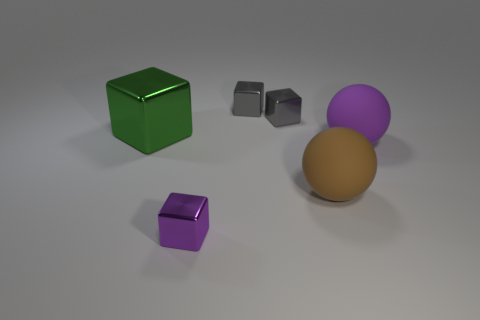There is a large thing on the left side of the purple thing that is in front of the brown rubber thing; is there a green cube that is left of it? After reviewing the image, the answer to whether there is a green cube left of the larger object that sits on the left side of the purple object in front of the brown object is indeed 'no'. The green cube is actually located to the right of the purple object and it is on the same side as the brown sphere. 